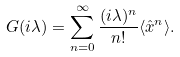<formula> <loc_0><loc_0><loc_500><loc_500>G ( i \lambda ) = \sum _ { n = 0 } ^ { \infty } \frac { ( i \lambda ) ^ { n } } { n ! } \langle { \hat { x } } ^ { n } \rangle .</formula> 